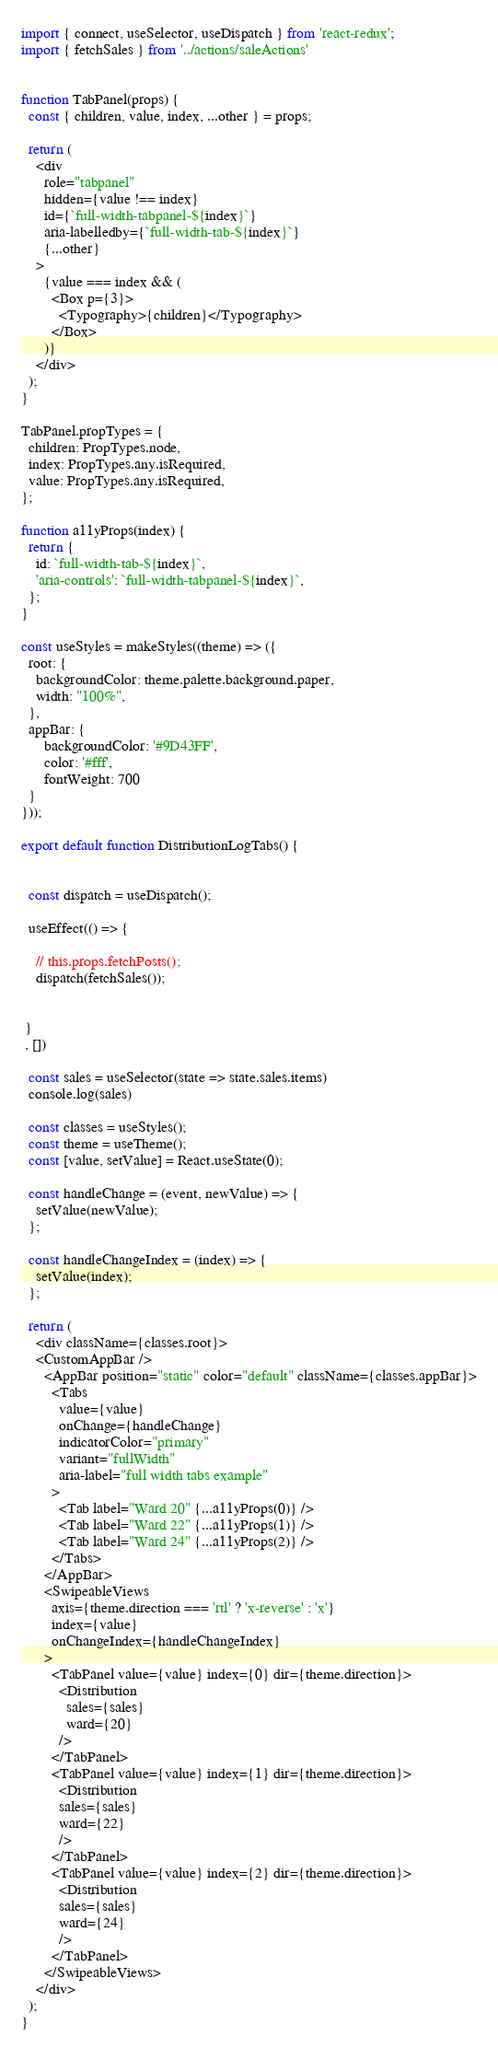Convert code to text. <code><loc_0><loc_0><loc_500><loc_500><_JavaScript_>
import { connect, useSelector, useDispatch } from 'react-redux';
import { fetchSales } from '../actions/saleActions'


function TabPanel(props) {
  const { children, value, index, ...other } = props;

  return (
    <div
      role="tabpanel"
      hidden={value !== index}
      id={`full-width-tabpanel-${index}`}
      aria-labelledby={`full-width-tab-${index}`}
      {...other}
    >
      {value === index && (
        <Box p={3}>
          <Typography>{children}</Typography>
        </Box>
      )}
    </div>
  );
}

TabPanel.propTypes = {
  children: PropTypes.node,
  index: PropTypes.any.isRequired,
  value: PropTypes.any.isRequired,
};

function a11yProps(index) {
  return {
    id: `full-width-tab-${index}`,
    'aria-controls': `full-width-tabpanel-${index}`,
  };
}

const useStyles = makeStyles((theme) => ({
  root: {
    backgroundColor: theme.palette.background.paper,
    width: "100%",
  },
  appBar: {
      backgroundColor: '#9D43FF',
      color: '#fff',
      fontWeight: 700
  }
}));

export default function DistributionLogTabs() {


  const dispatch = useDispatch();

  useEffect(() => {

    // this.props.fetchPosts();    
    dispatch(fetchSales());
    
    
 }
 , [])

  const sales = useSelector(state => state.sales.items)
  console.log(sales)

  const classes = useStyles();
  const theme = useTheme();
  const [value, setValue] = React.useState(0);

  const handleChange = (event, newValue) => {
    setValue(newValue);
  };

  const handleChangeIndex = (index) => {
    setValue(index);
  };

  return (
    <div className={classes.root}>
    <CustomAppBar />
      <AppBar position="static" color="default" className={classes.appBar}>
        <Tabs
          value={value}
          onChange={handleChange}
          indicatorColor="primary"
          variant="fullWidth"
          aria-label="full width tabs example"
        >
          <Tab label="Ward 20" {...a11yProps(0)} />
          <Tab label="Ward 22" {...a11yProps(1)} />
          <Tab label="Ward 24" {...a11yProps(2)} />
        </Tabs>
      </AppBar>
      <SwipeableViews
        axis={theme.direction === 'rtl' ? 'x-reverse' : 'x'}
        index={value}
        onChangeIndex={handleChangeIndex}
      >
        <TabPanel value={value} index={0} dir={theme.direction}>
          <Distribution
            sales={sales}
            ward={20}
          />
        </TabPanel>
        <TabPanel value={value} index={1} dir={theme.direction}>
          <Distribution
          sales={sales}
          ward={22}
          />
        </TabPanel>
        <TabPanel value={value} index={2} dir={theme.direction}>
          <Distribution
          sales={sales}
          ward={24}
          />
        </TabPanel>
      </SwipeableViews>
    </div>
  );
}
</code> 